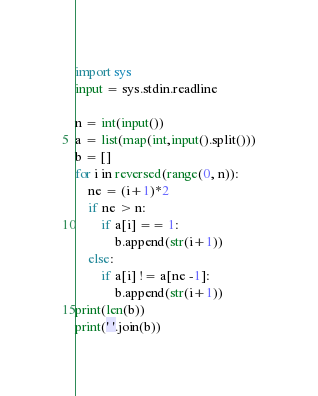Convert code to text. <code><loc_0><loc_0><loc_500><loc_500><_Python_>import sys
input = sys.stdin.readline

n = int(input())
a = list(map(int,input().split()))
b = []
for i in reversed(range(0, n)):
    ne = (i+1)*2
    if ne > n:
        if a[i] == 1:
            b.append(str(i+1))
    else:
        if a[i] != a[ne -1]:
            b.append(str(i+1))
print(len(b))
print(' '.join(b))</code> 